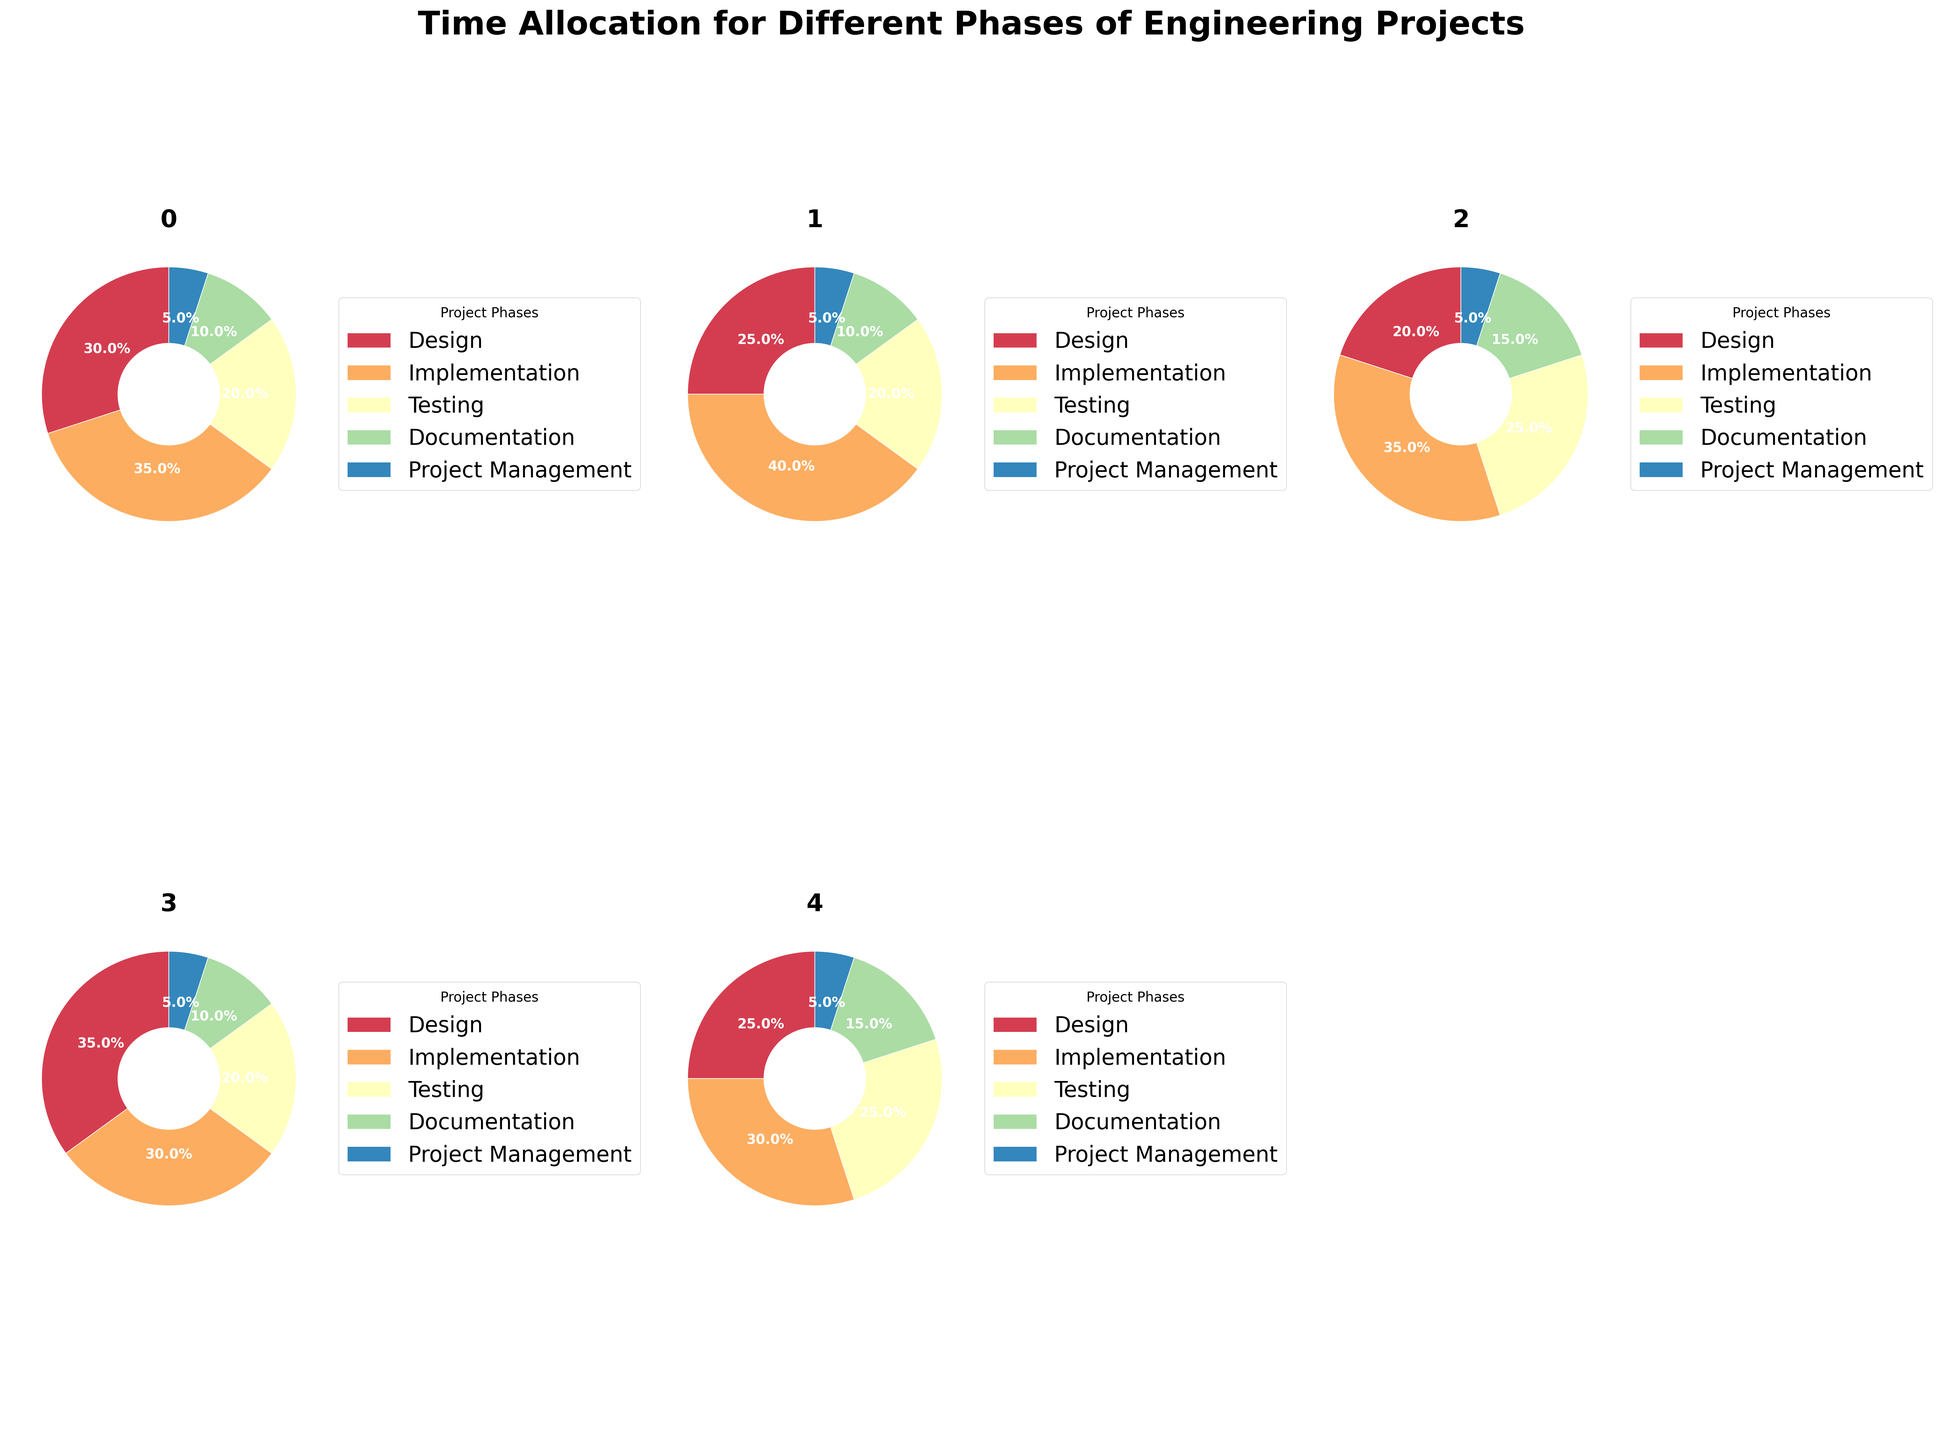What is the title of the figure? The title is displayed at the top of the figure. It reads "Time Allocation for Different Phases of Engineering Projects."
Answer: Time Allocation for Different Phases of Engineering Projects What percentage of time is allocated to Implementation in Electrical Engineering projects? In the pie chart for Electrical Engineering, the Implementation wedge is labeled with its percentage.
Answer: 40% Which engineering field allocates the highest percentage of time to Testing? By examining the segments labeled for Testing across all pie charts, the Software Engineering pie chart shows the largest Testing segment.
Answer: Software Engineering Compare the time allocated to Design in Mechanical Engineering and Civil Engineering projects. Which field allocates more time? In their respective pie charts, Mechanical Engineering and Civil Engineering have the Design segments labeled as 30% and 35%, respectively.
Answer: Civil Engineering How much total time is allocated to Documentation and Project Management in Software Engineering projects? Sum the percentages of Documentation and Project Management in the Software Engineering pie chart: 15% (Documentation) + 5% (Project Management).
Answer: 20% Which two engineering fields allocate a greater or equal percentage of time to Design compared to Electrical Engineering? Electrical Engineering allocates 25% to Design. Mechanical Engineering (30%) and Civil Engineering (35%) both allocate a higher percentage.
Answer: Mechanical Engineering and Civil Engineering What's the combined percentage of time allocated to Testing across all five engineering fields? Sum the Testing percentages: ME: 20%, EE: 20%, SE: 25%, CE: 20%, ChE: 25%. Total = 20+ 20 + 25 + 20 + 25.
Answer: 110% How do time allocations for Documentation in Software Engineering and Chemical Engineering compare? Both Software Engineering and Chemical Engineering allocate 15% to Documentation, as visible in their respective pie charts.
Answer: They are equal If you had to manage a Mechanical Engineering project, which two phases should receive more focus based on the time allocation? Design (30%) and Implementation (35%) are the largest segments in the Mechanical Engineering pie chart.
Answer: Design and Implementation Which engineering field allocates the smallest percentage of time to Project Management? All fields allocate 5% to Project Management, so none allocate less.
Answer: None allocate less 